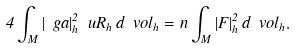Convert formula to latex. <formula><loc_0><loc_0><loc_500><loc_500>4 \int _ { M } | \ g a | _ { h } ^ { 2 } \ u R _ { h } \, d \ v o l _ { h } = n \int _ { M } | F | _ { h } ^ { 2 } \, d \ v o l _ { h } .</formula> 